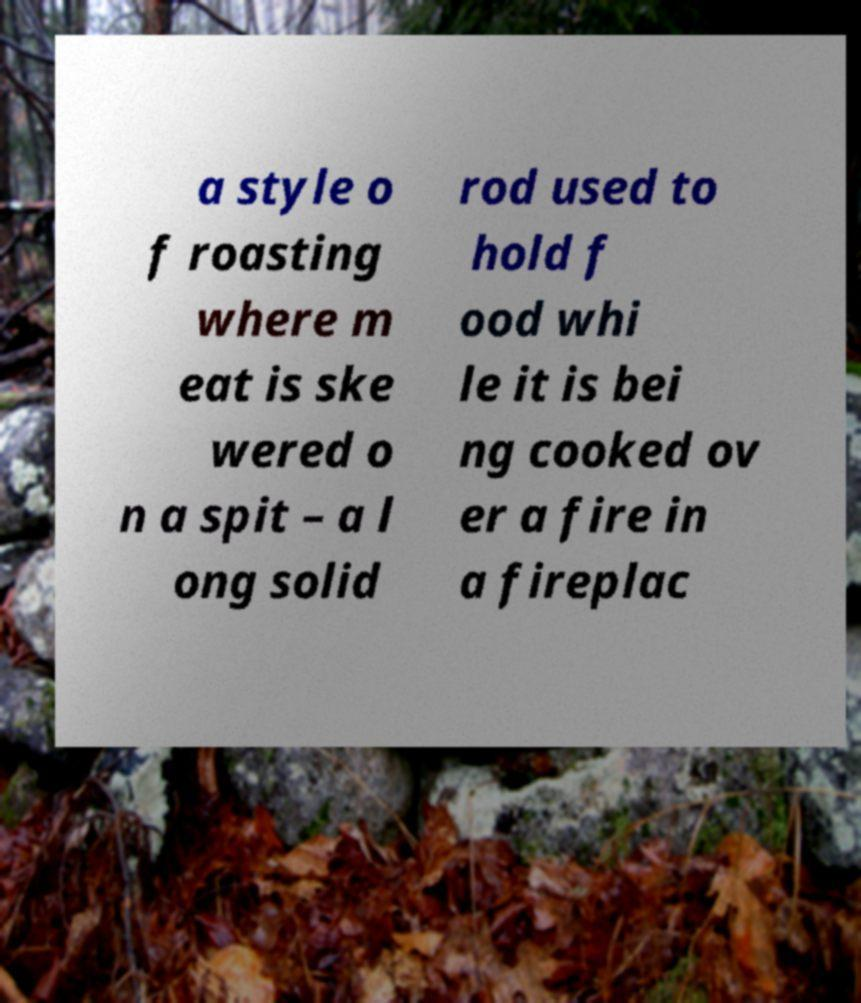Please read and relay the text visible in this image. What does it say? a style o f roasting where m eat is ske wered o n a spit – a l ong solid rod used to hold f ood whi le it is bei ng cooked ov er a fire in a fireplac 